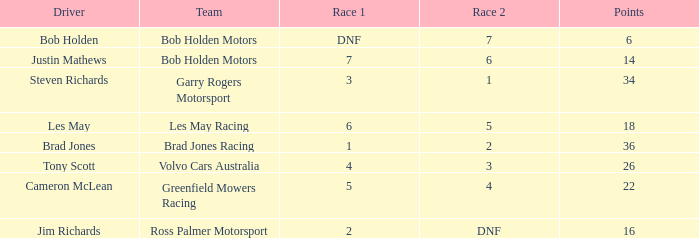Which driver for Greenfield Mowers Racing has fewer than 36 points? Cameron McLean. 